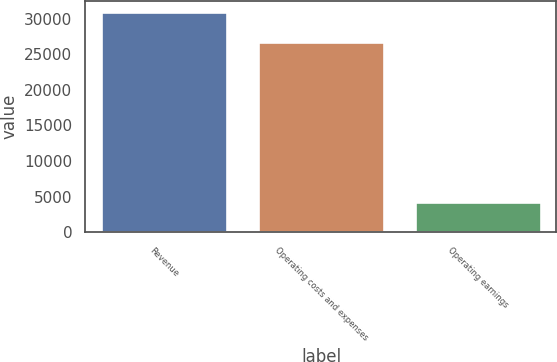<chart> <loc_0><loc_0><loc_500><loc_500><bar_chart><fcel>Revenue<fcel>Operating costs and expenses<fcel>Operating earnings<nl><fcel>30973<fcel>26737<fcel>4236<nl></chart> 